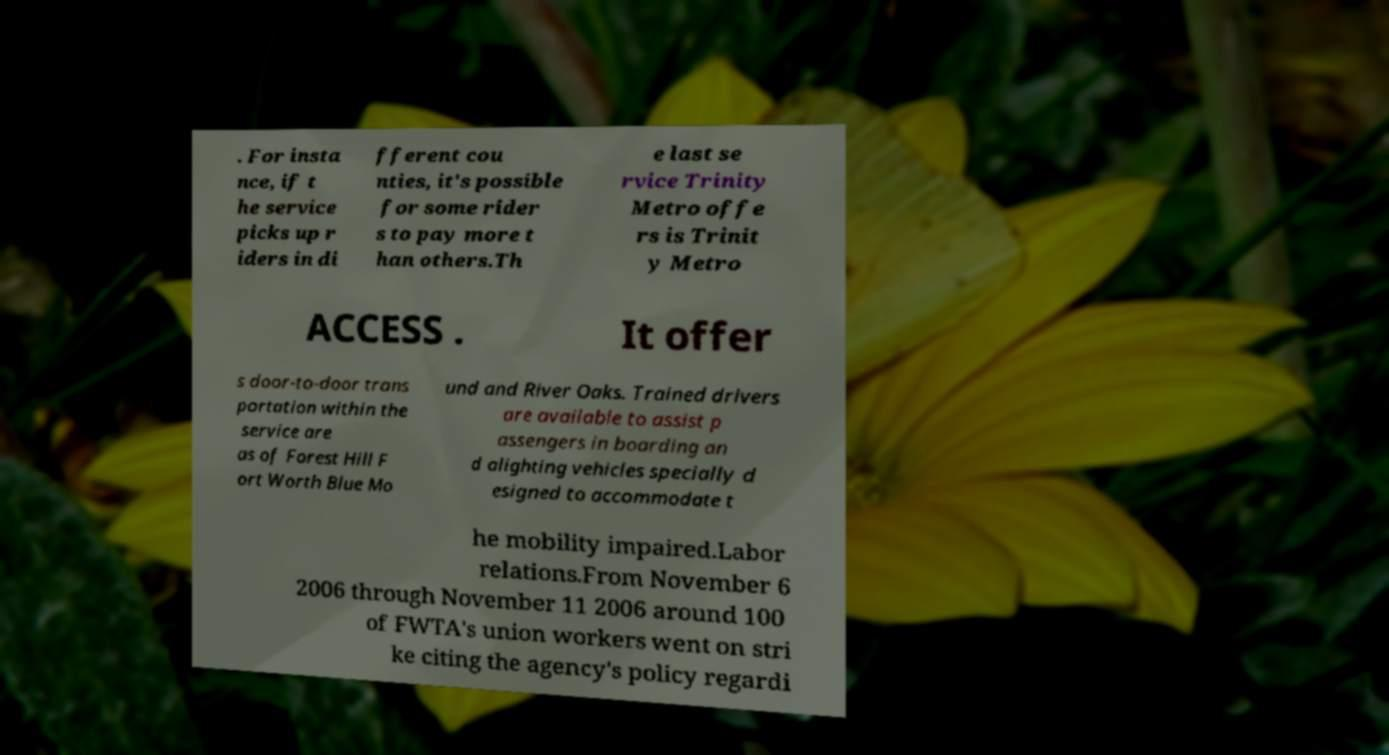Could you assist in decoding the text presented in this image and type it out clearly? . For insta nce, if t he service picks up r iders in di fferent cou nties, it's possible for some rider s to pay more t han others.Th e last se rvice Trinity Metro offe rs is Trinit y Metro ACCESS . It offer s door-to-door trans portation within the service are as of Forest Hill F ort Worth Blue Mo und and River Oaks. Trained drivers are available to assist p assengers in boarding an d alighting vehicles specially d esigned to accommodate t he mobility impaired.Labor relations.From November 6 2006 through November 11 2006 around 100 of FWTA's union workers went on stri ke citing the agency's policy regardi 